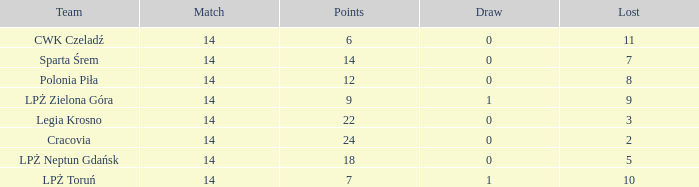What is the highest loss with points less than 7? 11.0. 